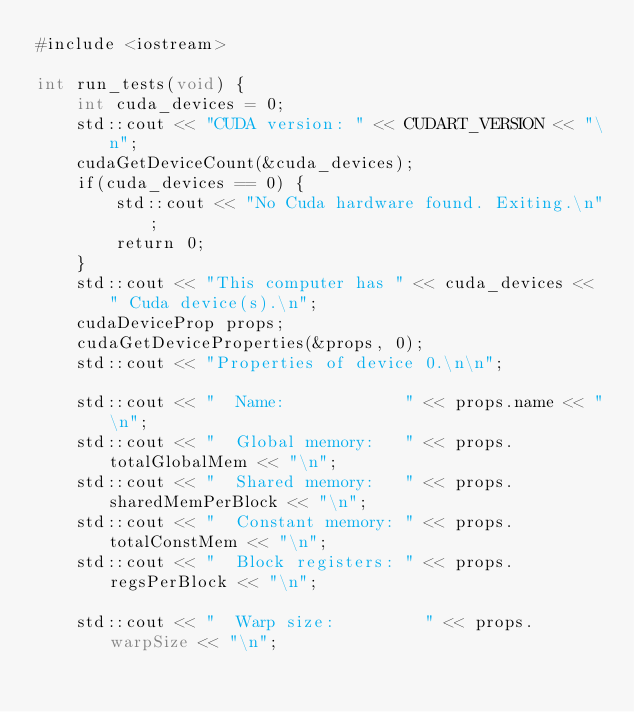<code> <loc_0><loc_0><loc_500><loc_500><_Cuda_>#include <iostream>

int run_tests(void) {
    int cuda_devices = 0;
    std::cout << "CUDA version: " << CUDART_VERSION << "\n";
    cudaGetDeviceCount(&cuda_devices);
    if(cuda_devices == 0) {
        std::cout << "No Cuda hardware found. Exiting.\n";
        return 0;
    }
    std::cout << "This computer has " << cuda_devices << " Cuda device(s).\n";
    cudaDeviceProp props;
    cudaGetDeviceProperties(&props, 0);
    std::cout << "Properties of device 0.\n\n";

    std::cout << "  Name:            " << props.name << "\n";
    std::cout << "  Global memory:   " << props.totalGlobalMem << "\n";
    std::cout << "  Shared memory:   " << props.sharedMemPerBlock << "\n";
    std::cout << "  Constant memory: " << props.totalConstMem << "\n";
    std::cout << "  Block registers: " << props.regsPerBlock << "\n";

    std::cout << "  Warp size:         " << props.warpSize << "\n";</code> 